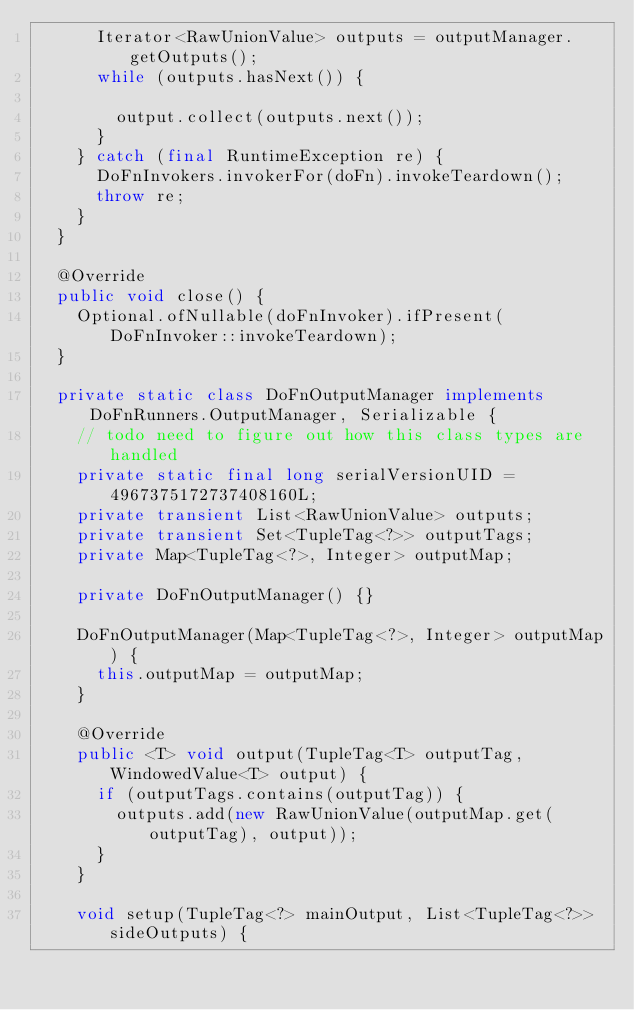<code> <loc_0><loc_0><loc_500><loc_500><_Java_>      Iterator<RawUnionValue> outputs = outputManager.getOutputs();
      while (outputs.hasNext()) {

        output.collect(outputs.next());
      }
    } catch (final RuntimeException re) {
      DoFnInvokers.invokerFor(doFn).invokeTeardown();
      throw re;
    }
  }

  @Override
  public void close() {
    Optional.ofNullable(doFnInvoker).ifPresent(DoFnInvoker::invokeTeardown);
  }

  private static class DoFnOutputManager implements DoFnRunners.OutputManager, Serializable {
    // todo need to figure out how this class types are handled
    private static final long serialVersionUID = 4967375172737408160L;
    private transient List<RawUnionValue> outputs;
    private transient Set<TupleTag<?>> outputTags;
    private Map<TupleTag<?>, Integer> outputMap;

    private DoFnOutputManager() {}

    DoFnOutputManager(Map<TupleTag<?>, Integer> outputMap) {
      this.outputMap = outputMap;
    }

    @Override
    public <T> void output(TupleTag<T> outputTag, WindowedValue<T> output) {
      if (outputTags.contains(outputTag)) {
        outputs.add(new RawUnionValue(outputMap.get(outputTag), output));
      }
    }

    void setup(TupleTag<?> mainOutput, List<TupleTag<?>> sideOutputs) {</code> 